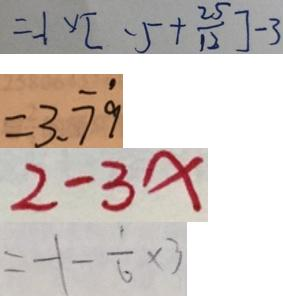Convert formula to latex. <formula><loc_0><loc_0><loc_500><loc_500>= - 1 \times [ - 5 + \frac { 2 5 } { 1 2 } ] - 3 
 = 3 . \dot { 7 } \dot { 9 } 
 2 - 3 x 
 = - 1 - \frac { 1 } { 6 } \times 3</formula> 